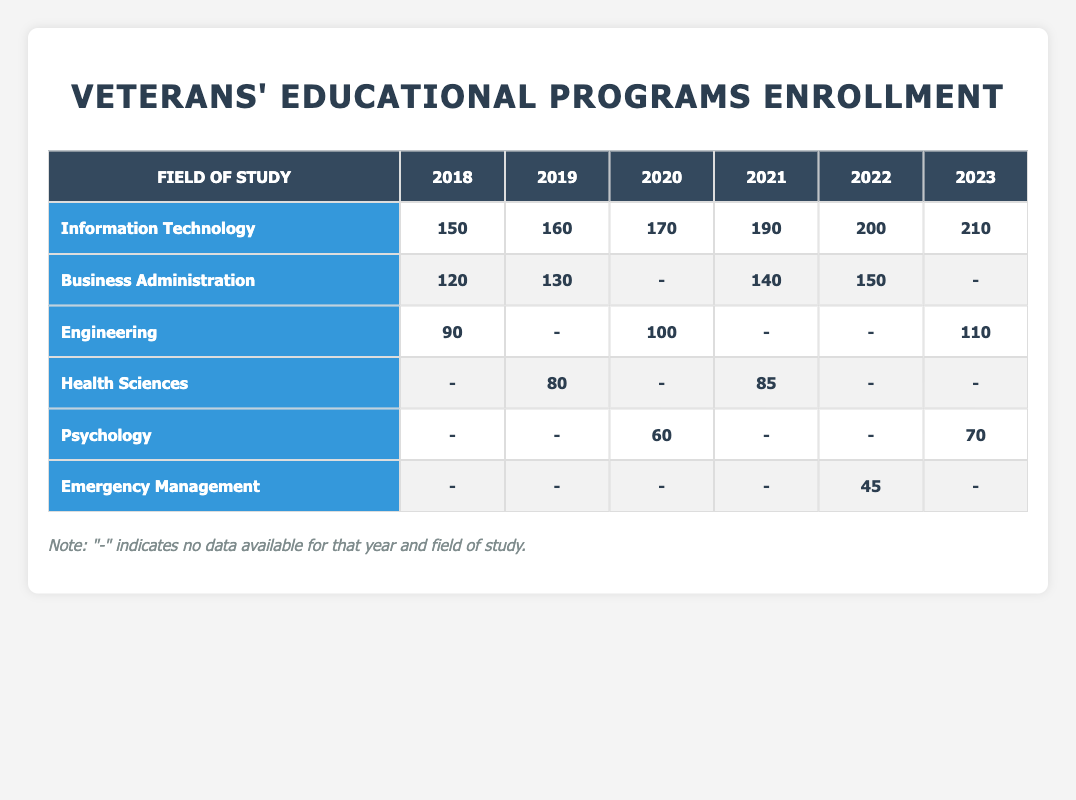What was the enrollment count for Information Technology in 2022? In the row for Information Technology, I can see the enrollment count for the year 2022 directly listed. It states 200.
Answer: 200 Which year had the highest enrollment in Business Administration? The enrollment counts for Business Administration across the years are 120 (2018), 130 (2019), 140 (2021), and 150 (2022). The highest value among these is 150 in 2022.
Answer: 150 in 2022 How many veterans enrolled in Health Sciences from 2018 to 2021 in total? The enrollment counts for Health Sciences are 0 in 2018, 80 in 2019, 0 in 2020, and 85 in 2021. Adding these counts gives 0 + 80 + 0 + 85 = 165.
Answer: 165 Is there any enrollment data available for Engineering in 2019? Looking at the row for Engineering, there's no data available for the year 2019, indicated with a "-". Thus, the answer is no.
Answer: No What field of study had the least enrollment count in 2020? The enrollment counts in 2020 are Information Technology (170), Psychology (60), and Engineering (100). The least value here is 60 for Psychology.
Answer: Psychology with 60 What was the increase in enrollment for Information Technology from 2018 to 2023? The enrollment counts for Information Technology from 2018 to 2023 are 150 (2018) and 210 (2023). The increase can be calculated as 210 - 150 = 60.
Answer: 60 In what year did the enrollment in Emergency Management reach 45? The enrollment data for Emergency Management shows a count of 45 only in 2022. Thus, it reached that number in 2022.
Answer: 2022 Did more veterans enroll in Psychology in 2023 than in 2020? The enrollment count for Psychology in 2020 is 60, while in 2023 it's 70. Since 70 is greater than 60, the answer is yes.
Answer: Yes What is the average enrollment count for Business Administration over the years it has data? The available enrollment counts for Business Administration are 120 (2018), 130 (2019), 140 (2021), and 150 (2022). The average can be calculated as (120 + 130 + 140 + 150) / 4 = 135.
Answer: 135 